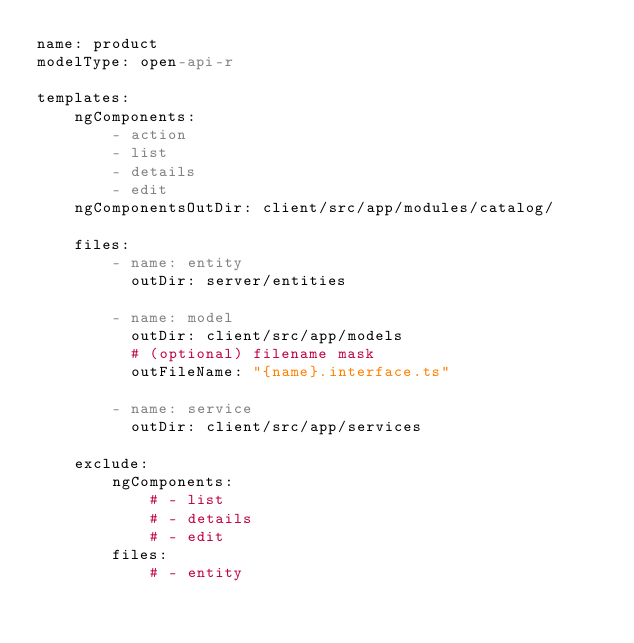<code> <loc_0><loc_0><loc_500><loc_500><_YAML_>name: product
modelType: open-api-r

templates:
    ngComponents:
        - action
        - list
        - details
        - edit
    ngComponentsOutDir: client/src/app/modules/catalog/

    files:
        - name: entity
          outDir: server/entities

        - name: model
          outDir: client/src/app/models
          # (optional) filename mask
          outFileName: "{name}.interface.ts"

        - name: service
          outDir: client/src/app/services

    exclude:
        ngComponents:
            # - list
            # - details
            # - edit
        files:
            # - entity</code> 